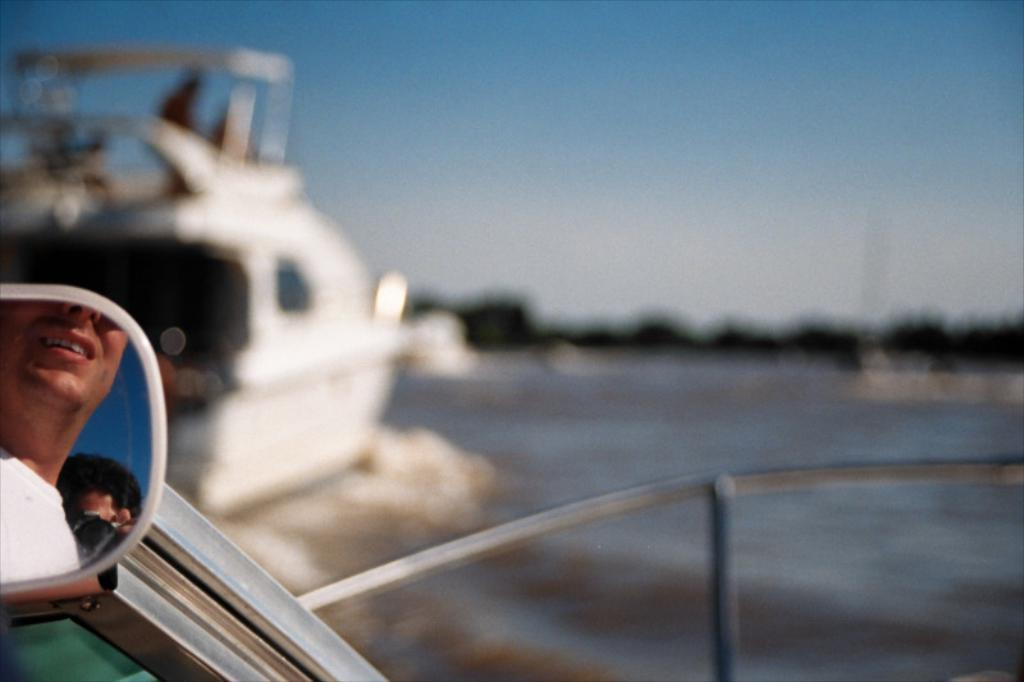What is: What is the main subject of the image? The main subject of the image is a person visible in a mirror. What else can be seen in the image besides the person in the mirror? There is a ship in the image. What type of environment is visible in the background of the image? Greenery is visible in the background of the image. What page is the person reading in the image? There is no indication in the image that the person is reading a page, as the focus is on their reflection in the mirror. 